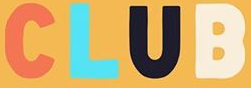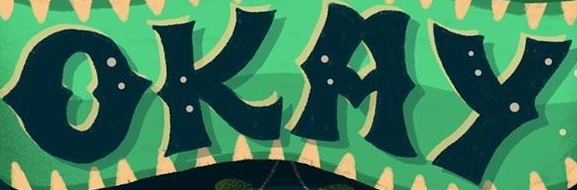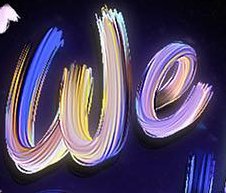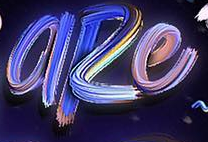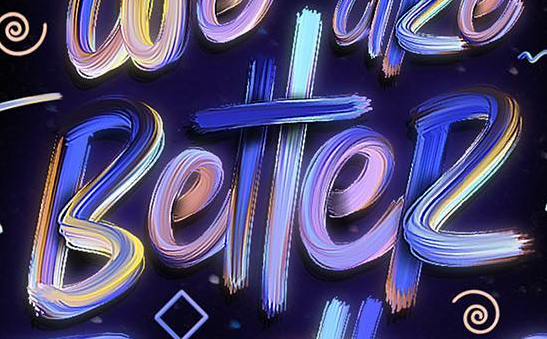Read the text content from these images in order, separated by a semicolon. CLUB; OKAY; we; aRe; BetteR 